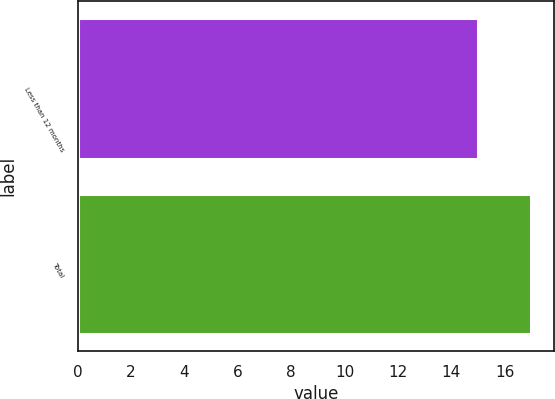<chart> <loc_0><loc_0><loc_500><loc_500><bar_chart><fcel>Less than 12 months<fcel>Total<nl><fcel>15<fcel>17<nl></chart> 